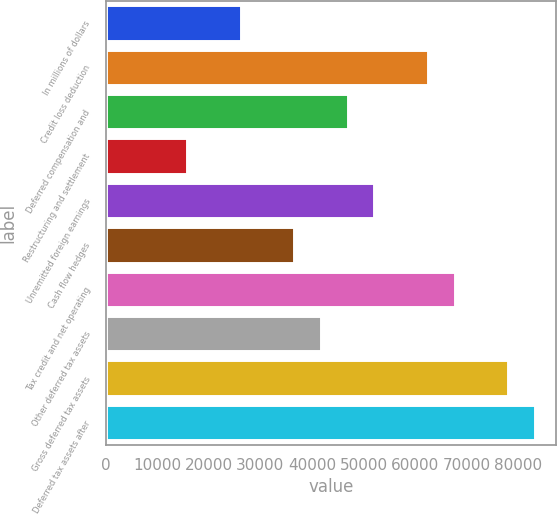Convert chart to OTSL. <chart><loc_0><loc_0><loc_500><loc_500><bar_chart><fcel>In millions of dollars<fcel>Credit loss deduction<fcel>Deferred compensation and<fcel>Restructuring and settlement<fcel>Unremitted foreign earnings<fcel>Cash flow hedges<fcel>Tax credit and net operating<fcel>Other deferred tax assets<fcel>Gross deferred tax assets<fcel>Deferred tax assets after<nl><fcel>26147<fcel>62451.8<fcel>46892.6<fcel>15774.2<fcel>52079<fcel>36519.8<fcel>67638.2<fcel>41706.2<fcel>78011<fcel>83197.4<nl></chart> 